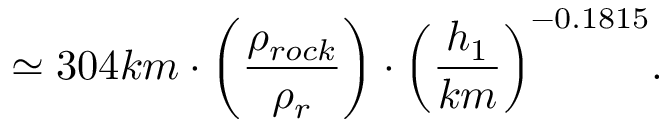<formula> <loc_0><loc_0><loc_500><loc_500>{ \simeq 3 0 4 k m \cdot \left ( \frac { \rho _ { r o c k } } { \rho _ { r } } \right ) } \cdot { \left ( \frac { h _ { 1 } } { k m } \right ) ^ { - 0 . 1 8 1 5 } } .</formula> 